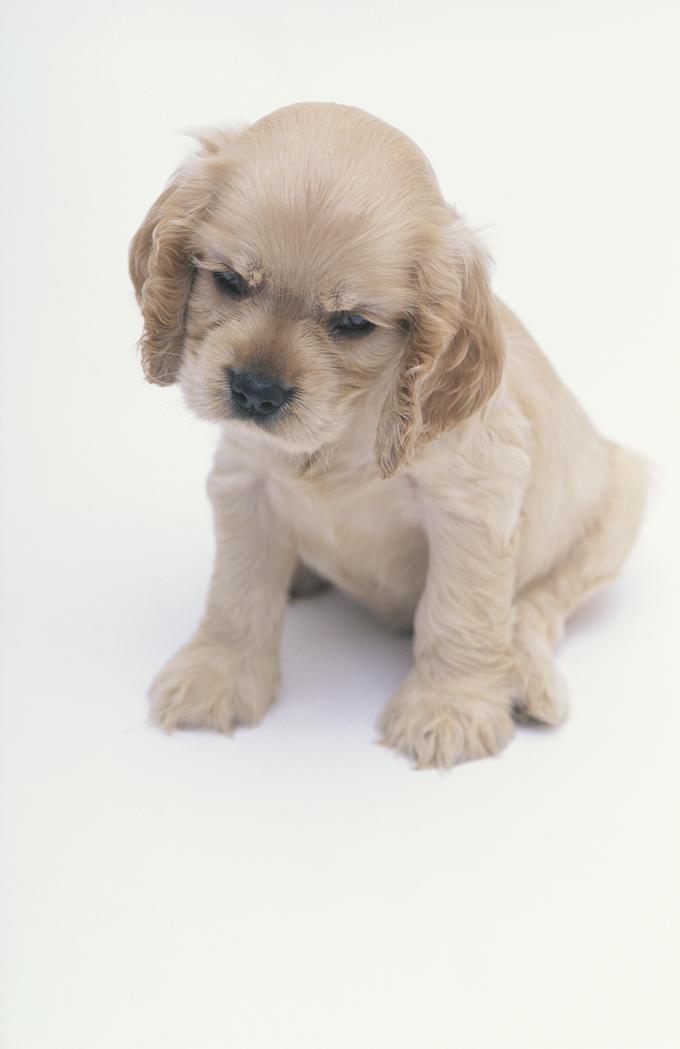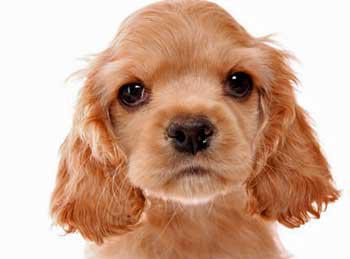The first image is the image on the left, the second image is the image on the right. Given the left and right images, does the statement "One of the dogs is wearing a dog collar." hold true? Answer yes or no. No. The first image is the image on the left, the second image is the image on the right. Considering the images on both sides, is "The animal in one of the images is on a white background" valid? Answer yes or no. Yes. 